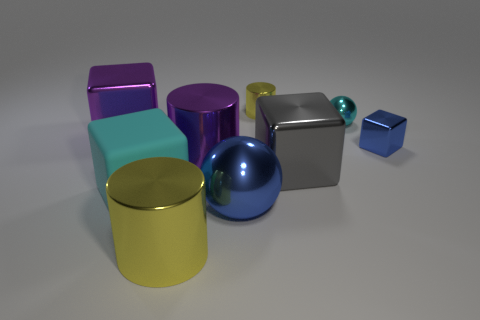What is the blue object in front of the big gray block made of?
Your response must be concise. Metal. There is a yellow metal cylinder that is on the right side of the big sphere; does it have the same size as the cyan thing in front of the small cyan object?
Keep it short and to the point. No. The small sphere has what color?
Make the answer very short. Cyan. There is a yellow object that is behind the large yellow cylinder; is it the same shape as the tiny cyan object?
Make the answer very short. No. What is the tiny cyan thing made of?
Your answer should be compact. Metal. There is a gray thing that is the same size as the cyan block; what is its shape?
Provide a short and direct response. Cube. Is there another cylinder that has the same color as the small shiny cylinder?
Your answer should be very brief. Yes. There is a small shiny block; does it have the same color as the big metal cube that is left of the matte object?
Keep it short and to the point. No. The sphere that is behind the metal cube that is behind the blue block is what color?
Ensure brevity in your answer.  Cyan. Is there a object in front of the yellow cylinder that is in front of the blue thing on the left side of the blue block?
Your answer should be very brief. No. 